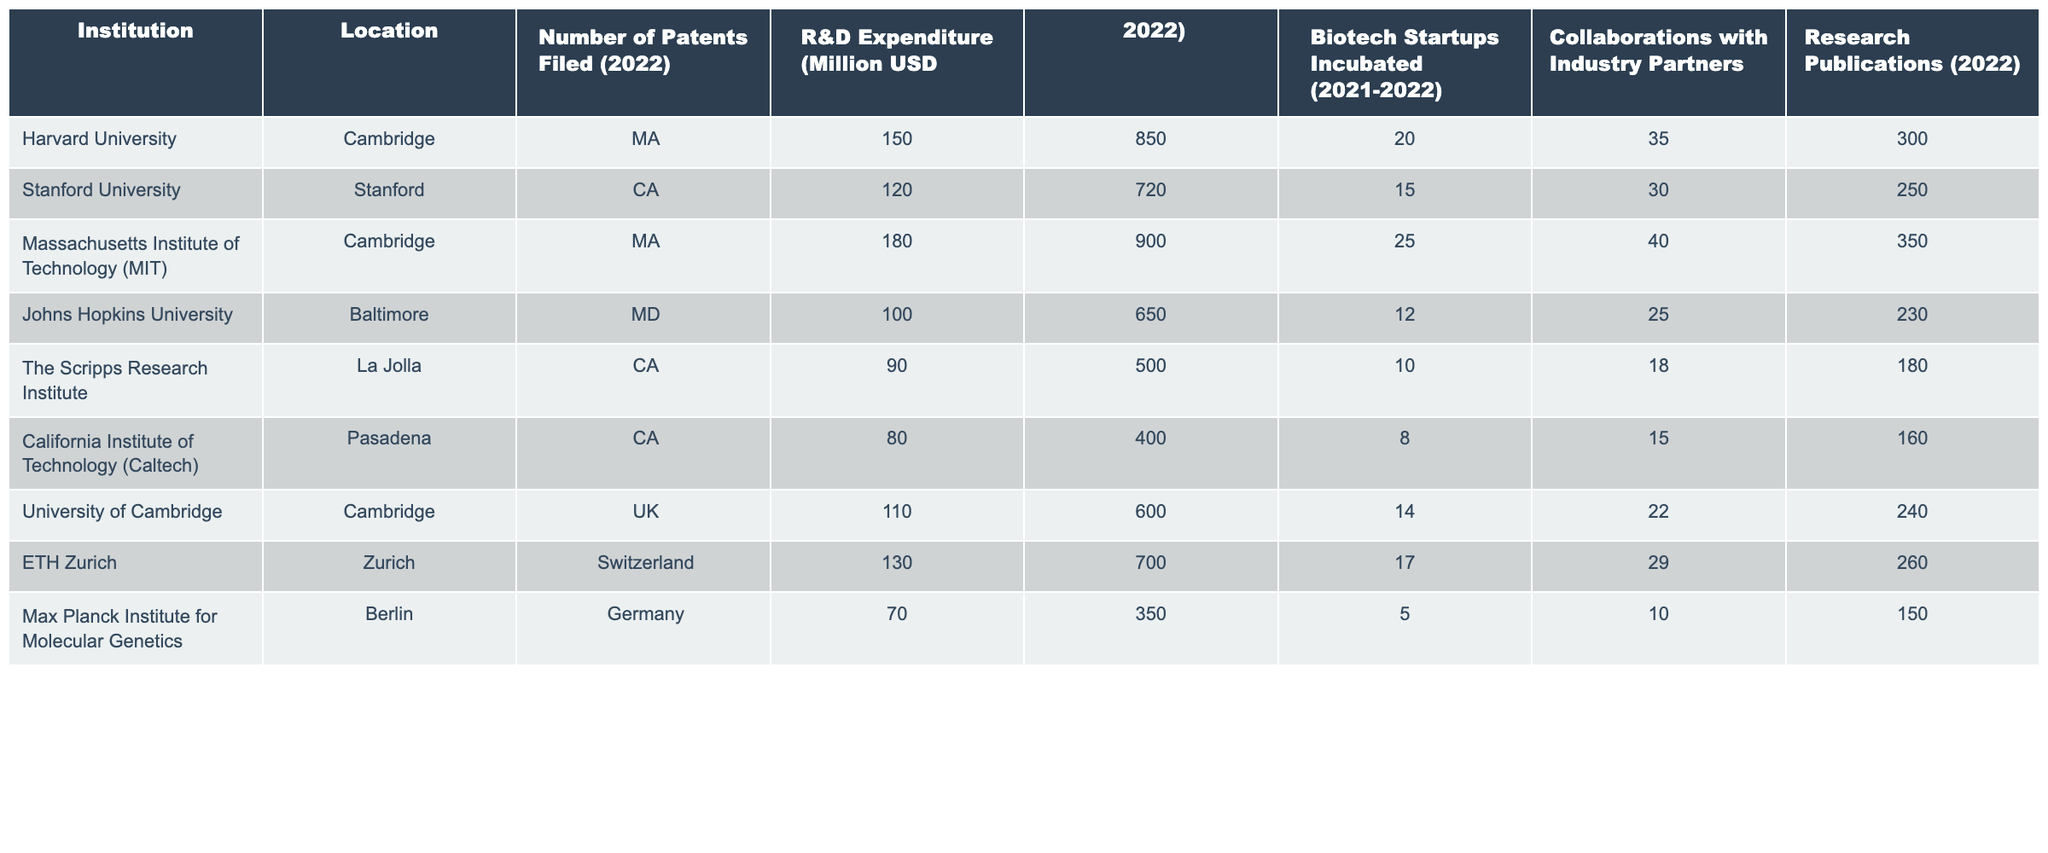What institution filed the highest number of patents in 2022? The table shows the number of patents filed by each institution in 2022. Harvard University filed 150 patents, while MIT filed the highest with 180 patents.
Answer: MIT What was the R&D expenditure of Johns Hopkins University in 2022? The table lists the R&D expenditure for each institution. Johns Hopkins University had an R&D expenditure of 650 million USD in 2022.
Answer: 650 million USD Which institution incubated the most biotech startups between 2021 and 2022? The table displays the number of biotech startups incubated by each institution during this period. MIT incubated 25 startups, the highest among the listed institutions.
Answer: MIT What is the total number of research publications across all institutions in 2022? To find the total, add all the research publications from each institution: 300 + 250 + 350 + 230 + 180 + 160 + 240 + 260 + 150 = 1870.
Answer: 1870 Did California Institute of Technology have more patents filed than the Max Planck Institute for Molecular Genetics? The table shows that Caltech filed 80 patents, while the Max Planck Institute filed only 70 patents. Therefore, Caltech had more patents filed.
Answer: Yes What is the average R&D expenditure of the institutions listed? To calculate the average, sum the R&D expenditures: 850 + 720 + 900 + 650 + 500 + 400 + 600 + 700 + 350 = 4870 million USD and divide by the number of institutions, which is 9. The average is 4870 / 9 ≈ 541.11 million USD.
Answer: Approximately 541.11 million USD Which institution had the least number of collaborations with industry partners? The table shows the number of collaborations for each institution. The Max Planck Institute for Molecular Genetics had the least with just 10 collaborations.
Answer: Max Planck Institute for Molecular Genetics If you combine the patents filed by Harvard and Stanford, do they surpass MIT's total patents filed? Harvard filed 150 patents and Stanford filed 120, totaling 150 + 120 = 270 patents. MIT filed 180 patents, so 270 > 180, meaning the combined total does surpass MIT's total.
Answer: Yes 